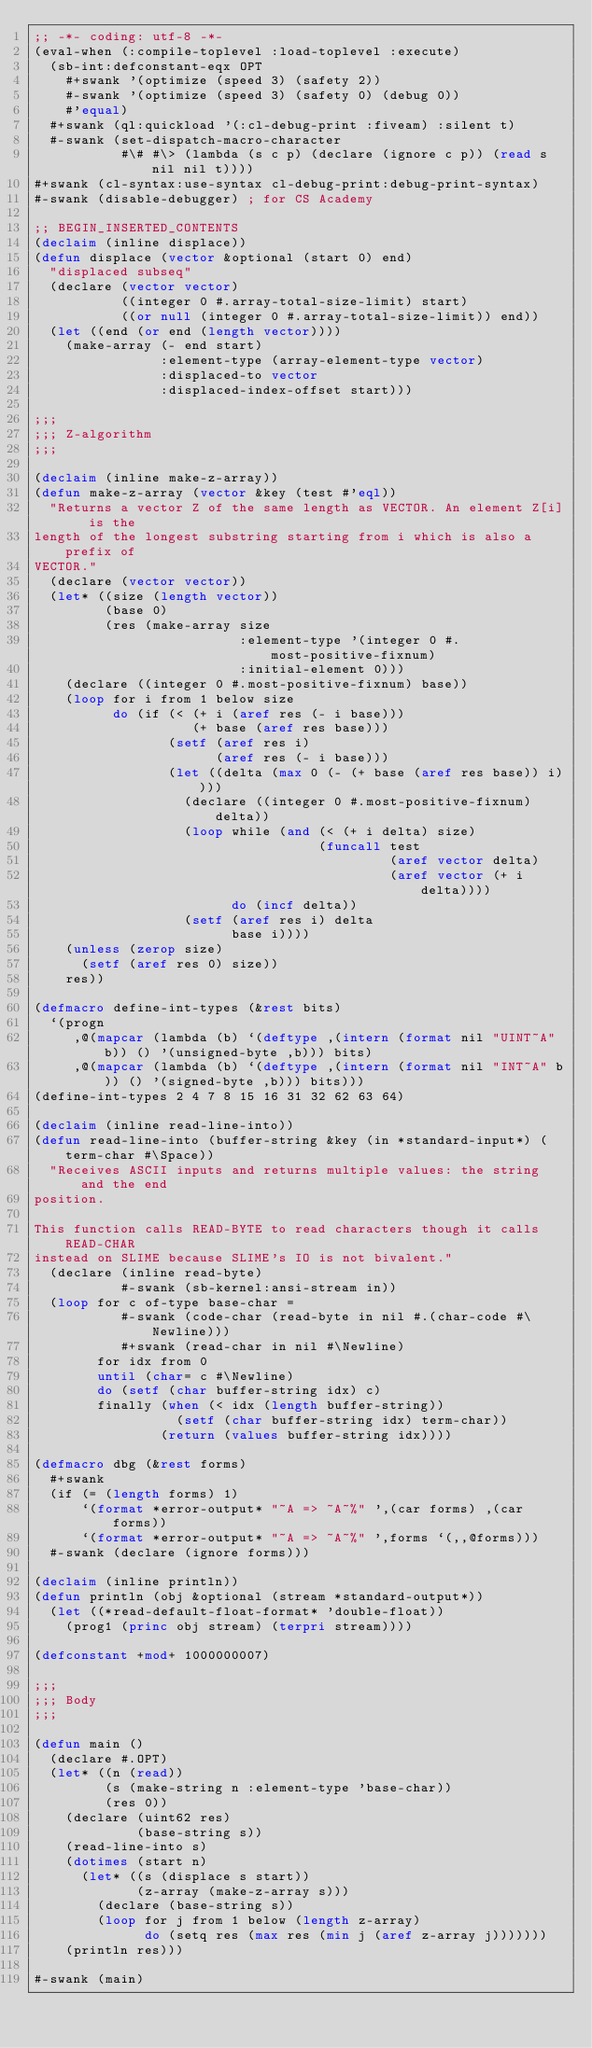Convert code to text. <code><loc_0><loc_0><loc_500><loc_500><_Lisp_>;; -*- coding: utf-8 -*-
(eval-when (:compile-toplevel :load-toplevel :execute)
  (sb-int:defconstant-eqx OPT
    #+swank '(optimize (speed 3) (safety 2))
    #-swank '(optimize (speed 3) (safety 0) (debug 0))
    #'equal)
  #+swank (ql:quickload '(:cl-debug-print :fiveam) :silent t)
  #-swank (set-dispatch-macro-character
           #\# #\> (lambda (s c p) (declare (ignore c p)) (read s nil nil t))))
#+swank (cl-syntax:use-syntax cl-debug-print:debug-print-syntax)
#-swank (disable-debugger) ; for CS Academy

;; BEGIN_INSERTED_CONTENTS
(declaim (inline displace))
(defun displace (vector &optional (start 0) end)
  "displaced subseq"
  (declare (vector vector)
           ((integer 0 #.array-total-size-limit) start)
           ((or null (integer 0 #.array-total-size-limit)) end))
  (let ((end (or end (length vector))))
    (make-array (- end start)
                :element-type (array-element-type vector)
                :displaced-to vector
                :displaced-index-offset start)))

;;;
;;; Z-algorithm
;;;

(declaim (inline make-z-array))
(defun make-z-array (vector &key (test #'eql))
  "Returns a vector Z of the same length as VECTOR. An element Z[i] is the
length of the longest substring starting from i which is also a prefix of
VECTOR."
  (declare (vector vector))
  (let* ((size (length vector))
         (base 0)
         (res (make-array size
                          :element-type '(integer 0 #.most-positive-fixnum)
                          :initial-element 0)))
    (declare ((integer 0 #.most-positive-fixnum) base))
    (loop for i from 1 below size
          do (if (< (+ i (aref res (- i base)))
                    (+ base (aref res base)))
                 (setf (aref res i)
                       (aref res (- i base)))
                 (let ((delta (max 0 (- (+ base (aref res base)) i))))
                   (declare ((integer 0 #.most-positive-fixnum) delta))
                   (loop while (and (< (+ i delta) size)
                                    (funcall test
                                             (aref vector delta)
                                             (aref vector (+ i delta))))
                         do (incf delta))
                   (setf (aref res i) delta
                         base i))))
    (unless (zerop size)
      (setf (aref res 0) size))
    res))

(defmacro define-int-types (&rest bits)
  `(progn
     ,@(mapcar (lambda (b) `(deftype ,(intern (format nil "UINT~A" b)) () '(unsigned-byte ,b))) bits)
     ,@(mapcar (lambda (b) `(deftype ,(intern (format nil "INT~A" b)) () '(signed-byte ,b))) bits)))
(define-int-types 2 4 7 8 15 16 31 32 62 63 64)

(declaim (inline read-line-into))
(defun read-line-into (buffer-string &key (in *standard-input*) (term-char #\Space))
  "Receives ASCII inputs and returns multiple values: the string and the end
position.

This function calls READ-BYTE to read characters though it calls READ-CHAR
instead on SLIME because SLIME's IO is not bivalent."
  (declare (inline read-byte)
           #-swank (sb-kernel:ansi-stream in))
  (loop for c of-type base-char =
           #-swank (code-char (read-byte in nil #.(char-code #\Newline)))
           #+swank (read-char in nil #\Newline)
        for idx from 0
        until (char= c #\Newline)
        do (setf (char buffer-string idx) c)
        finally (when (< idx (length buffer-string))
                  (setf (char buffer-string idx) term-char))
                (return (values buffer-string idx))))

(defmacro dbg (&rest forms)
  #+swank
  (if (= (length forms) 1)
      `(format *error-output* "~A => ~A~%" ',(car forms) ,(car forms))
      `(format *error-output* "~A => ~A~%" ',forms `(,,@forms)))
  #-swank (declare (ignore forms)))

(declaim (inline println))
(defun println (obj &optional (stream *standard-output*))
  (let ((*read-default-float-format* 'double-float))
    (prog1 (princ obj stream) (terpri stream))))

(defconstant +mod+ 1000000007)

;;;
;;; Body
;;;

(defun main ()
  (declare #.OPT)
  (let* ((n (read))
         (s (make-string n :element-type 'base-char))
         (res 0))
    (declare (uint62 res)
             (base-string s))
    (read-line-into s)
    (dotimes (start n)
      (let* ((s (displace s start))
             (z-array (make-z-array s)))
        (declare (base-string s))
        (loop for j from 1 below (length z-array)
              do (setq res (max res (min j (aref z-array j)))))))
    (println res)))

#-swank (main)
</code> 